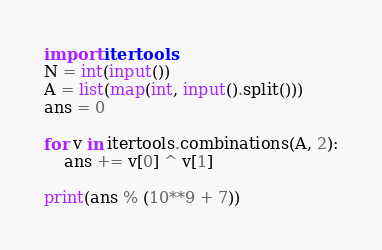Convert code to text. <code><loc_0><loc_0><loc_500><loc_500><_Python_>import itertools
N = int(input())
A = list(map(int, input().split()))
ans = 0

for v in itertools.combinations(A, 2):
    ans += v[0] ^ v[1]
    
print(ans % (10**9 + 7))</code> 